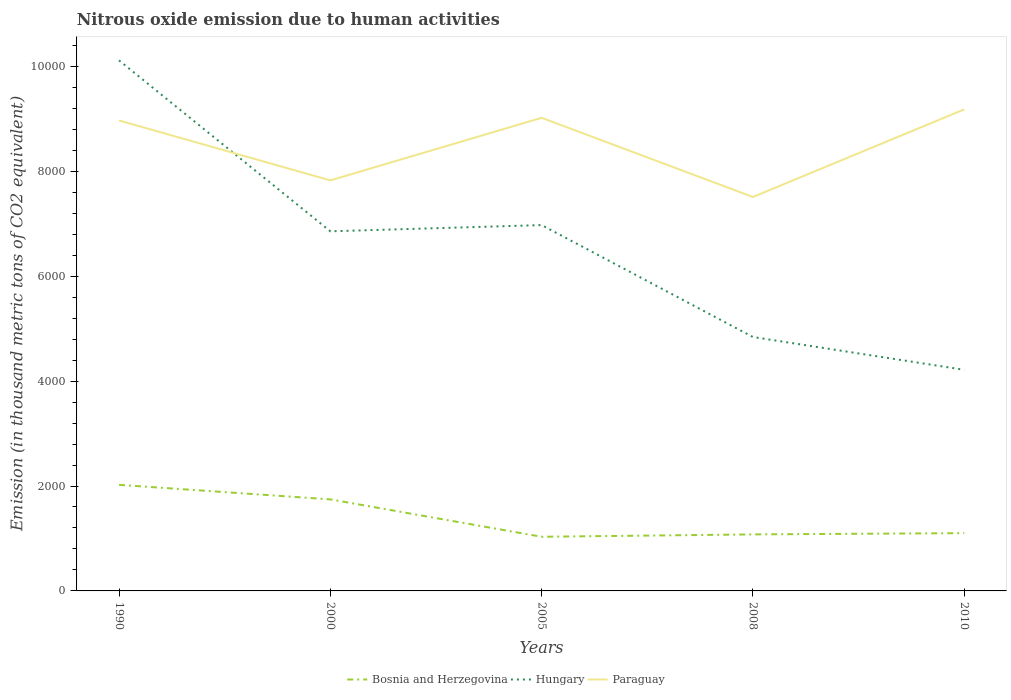How many different coloured lines are there?
Offer a terse response. 3. Does the line corresponding to Bosnia and Herzegovina intersect with the line corresponding to Hungary?
Make the answer very short. No. Is the number of lines equal to the number of legend labels?
Offer a terse response. Yes. Across all years, what is the maximum amount of nitrous oxide emitted in Bosnia and Herzegovina?
Offer a terse response. 1032.3. In which year was the amount of nitrous oxide emitted in Hungary maximum?
Provide a succinct answer. 2010. What is the total amount of nitrous oxide emitted in Paraguay in the graph?
Provide a succinct answer. -1354. What is the difference between the highest and the second highest amount of nitrous oxide emitted in Bosnia and Herzegovina?
Ensure brevity in your answer.  990.3. What is the difference between the highest and the lowest amount of nitrous oxide emitted in Bosnia and Herzegovina?
Provide a short and direct response. 2. Is the amount of nitrous oxide emitted in Bosnia and Herzegovina strictly greater than the amount of nitrous oxide emitted in Hungary over the years?
Provide a succinct answer. Yes. How many lines are there?
Provide a succinct answer. 3. How many years are there in the graph?
Your response must be concise. 5. What is the difference between two consecutive major ticks on the Y-axis?
Keep it short and to the point. 2000. Are the values on the major ticks of Y-axis written in scientific E-notation?
Provide a short and direct response. No. Does the graph contain any zero values?
Offer a terse response. No. How are the legend labels stacked?
Your response must be concise. Horizontal. What is the title of the graph?
Give a very brief answer. Nitrous oxide emission due to human activities. What is the label or title of the Y-axis?
Your answer should be compact. Emission (in thousand metric tons of CO2 equivalent). What is the Emission (in thousand metric tons of CO2 equivalent) in Bosnia and Herzegovina in 1990?
Provide a succinct answer. 2022.6. What is the Emission (in thousand metric tons of CO2 equivalent) in Hungary in 1990?
Ensure brevity in your answer.  1.01e+04. What is the Emission (in thousand metric tons of CO2 equivalent) of Paraguay in 1990?
Your answer should be compact. 8968.7. What is the Emission (in thousand metric tons of CO2 equivalent) of Bosnia and Herzegovina in 2000?
Keep it short and to the point. 1744.9. What is the Emission (in thousand metric tons of CO2 equivalent) of Hungary in 2000?
Your answer should be very brief. 6855.8. What is the Emission (in thousand metric tons of CO2 equivalent) of Paraguay in 2000?
Make the answer very short. 7826.3. What is the Emission (in thousand metric tons of CO2 equivalent) in Bosnia and Herzegovina in 2005?
Make the answer very short. 1032.3. What is the Emission (in thousand metric tons of CO2 equivalent) in Hungary in 2005?
Offer a terse response. 6974.6. What is the Emission (in thousand metric tons of CO2 equivalent) in Paraguay in 2005?
Keep it short and to the point. 9019.7. What is the Emission (in thousand metric tons of CO2 equivalent) in Bosnia and Herzegovina in 2008?
Give a very brief answer. 1077.6. What is the Emission (in thousand metric tons of CO2 equivalent) of Hungary in 2008?
Give a very brief answer. 4840.8. What is the Emission (in thousand metric tons of CO2 equivalent) of Paraguay in 2008?
Offer a very short reply. 7510.2. What is the Emission (in thousand metric tons of CO2 equivalent) in Bosnia and Herzegovina in 2010?
Make the answer very short. 1101.5. What is the Emission (in thousand metric tons of CO2 equivalent) in Hungary in 2010?
Ensure brevity in your answer.  4215.1. What is the Emission (in thousand metric tons of CO2 equivalent) of Paraguay in 2010?
Provide a short and direct response. 9180.3. Across all years, what is the maximum Emission (in thousand metric tons of CO2 equivalent) in Bosnia and Herzegovina?
Your response must be concise. 2022.6. Across all years, what is the maximum Emission (in thousand metric tons of CO2 equivalent) in Hungary?
Your answer should be compact. 1.01e+04. Across all years, what is the maximum Emission (in thousand metric tons of CO2 equivalent) of Paraguay?
Give a very brief answer. 9180.3. Across all years, what is the minimum Emission (in thousand metric tons of CO2 equivalent) of Bosnia and Herzegovina?
Offer a terse response. 1032.3. Across all years, what is the minimum Emission (in thousand metric tons of CO2 equivalent) in Hungary?
Your answer should be compact. 4215.1. Across all years, what is the minimum Emission (in thousand metric tons of CO2 equivalent) in Paraguay?
Your response must be concise. 7510.2. What is the total Emission (in thousand metric tons of CO2 equivalent) in Bosnia and Herzegovina in the graph?
Ensure brevity in your answer.  6978.9. What is the total Emission (in thousand metric tons of CO2 equivalent) of Hungary in the graph?
Ensure brevity in your answer.  3.30e+04. What is the total Emission (in thousand metric tons of CO2 equivalent) in Paraguay in the graph?
Keep it short and to the point. 4.25e+04. What is the difference between the Emission (in thousand metric tons of CO2 equivalent) of Bosnia and Herzegovina in 1990 and that in 2000?
Your answer should be very brief. 277.7. What is the difference between the Emission (in thousand metric tons of CO2 equivalent) of Hungary in 1990 and that in 2000?
Ensure brevity in your answer.  3258.4. What is the difference between the Emission (in thousand metric tons of CO2 equivalent) of Paraguay in 1990 and that in 2000?
Provide a succinct answer. 1142.4. What is the difference between the Emission (in thousand metric tons of CO2 equivalent) in Bosnia and Herzegovina in 1990 and that in 2005?
Give a very brief answer. 990.3. What is the difference between the Emission (in thousand metric tons of CO2 equivalent) of Hungary in 1990 and that in 2005?
Make the answer very short. 3139.6. What is the difference between the Emission (in thousand metric tons of CO2 equivalent) of Paraguay in 1990 and that in 2005?
Your answer should be compact. -51. What is the difference between the Emission (in thousand metric tons of CO2 equivalent) in Bosnia and Herzegovina in 1990 and that in 2008?
Your answer should be very brief. 945. What is the difference between the Emission (in thousand metric tons of CO2 equivalent) in Hungary in 1990 and that in 2008?
Give a very brief answer. 5273.4. What is the difference between the Emission (in thousand metric tons of CO2 equivalent) of Paraguay in 1990 and that in 2008?
Make the answer very short. 1458.5. What is the difference between the Emission (in thousand metric tons of CO2 equivalent) in Bosnia and Herzegovina in 1990 and that in 2010?
Your response must be concise. 921.1. What is the difference between the Emission (in thousand metric tons of CO2 equivalent) in Hungary in 1990 and that in 2010?
Give a very brief answer. 5899.1. What is the difference between the Emission (in thousand metric tons of CO2 equivalent) of Paraguay in 1990 and that in 2010?
Ensure brevity in your answer.  -211.6. What is the difference between the Emission (in thousand metric tons of CO2 equivalent) of Bosnia and Herzegovina in 2000 and that in 2005?
Keep it short and to the point. 712.6. What is the difference between the Emission (in thousand metric tons of CO2 equivalent) of Hungary in 2000 and that in 2005?
Give a very brief answer. -118.8. What is the difference between the Emission (in thousand metric tons of CO2 equivalent) of Paraguay in 2000 and that in 2005?
Give a very brief answer. -1193.4. What is the difference between the Emission (in thousand metric tons of CO2 equivalent) in Bosnia and Herzegovina in 2000 and that in 2008?
Keep it short and to the point. 667.3. What is the difference between the Emission (in thousand metric tons of CO2 equivalent) of Hungary in 2000 and that in 2008?
Make the answer very short. 2015. What is the difference between the Emission (in thousand metric tons of CO2 equivalent) of Paraguay in 2000 and that in 2008?
Ensure brevity in your answer.  316.1. What is the difference between the Emission (in thousand metric tons of CO2 equivalent) of Bosnia and Herzegovina in 2000 and that in 2010?
Offer a terse response. 643.4. What is the difference between the Emission (in thousand metric tons of CO2 equivalent) in Hungary in 2000 and that in 2010?
Make the answer very short. 2640.7. What is the difference between the Emission (in thousand metric tons of CO2 equivalent) in Paraguay in 2000 and that in 2010?
Offer a terse response. -1354. What is the difference between the Emission (in thousand metric tons of CO2 equivalent) in Bosnia and Herzegovina in 2005 and that in 2008?
Provide a succinct answer. -45.3. What is the difference between the Emission (in thousand metric tons of CO2 equivalent) of Hungary in 2005 and that in 2008?
Your response must be concise. 2133.8. What is the difference between the Emission (in thousand metric tons of CO2 equivalent) of Paraguay in 2005 and that in 2008?
Offer a terse response. 1509.5. What is the difference between the Emission (in thousand metric tons of CO2 equivalent) of Bosnia and Herzegovina in 2005 and that in 2010?
Make the answer very short. -69.2. What is the difference between the Emission (in thousand metric tons of CO2 equivalent) in Hungary in 2005 and that in 2010?
Provide a short and direct response. 2759.5. What is the difference between the Emission (in thousand metric tons of CO2 equivalent) of Paraguay in 2005 and that in 2010?
Your answer should be compact. -160.6. What is the difference between the Emission (in thousand metric tons of CO2 equivalent) of Bosnia and Herzegovina in 2008 and that in 2010?
Your answer should be compact. -23.9. What is the difference between the Emission (in thousand metric tons of CO2 equivalent) of Hungary in 2008 and that in 2010?
Keep it short and to the point. 625.7. What is the difference between the Emission (in thousand metric tons of CO2 equivalent) in Paraguay in 2008 and that in 2010?
Your answer should be compact. -1670.1. What is the difference between the Emission (in thousand metric tons of CO2 equivalent) of Bosnia and Herzegovina in 1990 and the Emission (in thousand metric tons of CO2 equivalent) of Hungary in 2000?
Your response must be concise. -4833.2. What is the difference between the Emission (in thousand metric tons of CO2 equivalent) in Bosnia and Herzegovina in 1990 and the Emission (in thousand metric tons of CO2 equivalent) in Paraguay in 2000?
Provide a succinct answer. -5803.7. What is the difference between the Emission (in thousand metric tons of CO2 equivalent) of Hungary in 1990 and the Emission (in thousand metric tons of CO2 equivalent) of Paraguay in 2000?
Offer a terse response. 2287.9. What is the difference between the Emission (in thousand metric tons of CO2 equivalent) of Bosnia and Herzegovina in 1990 and the Emission (in thousand metric tons of CO2 equivalent) of Hungary in 2005?
Ensure brevity in your answer.  -4952. What is the difference between the Emission (in thousand metric tons of CO2 equivalent) of Bosnia and Herzegovina in 1990 and the Emission (in thousand metric tons of CO2 equivalent) of Paraguay in 2005?
Give a very brief answer. -6997.1. What is the difference between the Emission (in thousand metric tons of CO2 equivalent) in Hungary in 1990 and the Emission (in thousand metric tons of CO2 equivalent) in Paraguay in 2005?
Provide a succinct answer. 1094.5. What is the difference between the Emission (in thousand metric tons of CO2 equivalent) in Bosnia and Herzegovina in 1990 and the Emission (in thousand metric tons of CO2 equivalent) in Hungary in 2008?
Your answer should be compact. -2818.2. What is the difference between the Emission (in thousand metric tons of CO2 equivalent) of Bosnia and Herzegovina in 1990 and the Emission (in thousand metric tons of CO2 equivalent) of Paraguay in 2008?
Your answer should be compact. -5487.6. What is the difference between the Emission (in thousand metric tons of CO2 equivalent) in Hungary in 1990 and the Emission (in thousand metric tons of CO2 equivalent) in Paraguay in 2008?
Offer a very short reply. 2604. What is the difference between the Emission (in thousand metric tons of CO2 equivalent) of Bosnia and Herzegovina in 1990 and the Emission (in thousand metric tons of CO2 equivalent) of Hungary in 2010?
Offer a terse response. -2192.5. What is the difference between the Emission (in thousand metric tons of CO2 equivalent) of Bosnia and Herzegovina in 1990 and the Emission (in thousand metric tons of CO2 equivalent) of Paraguay in 2010?
Give a very brief answer. -7157.7. What is the difference between the Emission (in thousand metric tons of CO2 equivalent) of Hungary in 1990 and the Emission (in thousand metric tons of CO2 equivalent) of Paraguay in 2010?
Offer a very short reply. 933.9. What is the difference between the Emission (in thousand metric tons of CO2 equivalent) of Bosnia and Herzegovina in 2000 and the Emission (in thousand metric tons of CO2 equivalent) of Hungary in 2005?
Offer a terse response. -5229.7. What is the difference between the Emission (in thousand metric tons of CO2 equivalent) of Bosnia and Herzegovina in 2000 and the Emission (in thousand metric tons of CO2 equivalent) of Paraguay in 2005?
Make the answer very short. -7274.8. What is the difference between the Emission (in thousand metric tons of CO2 equivalent) in Hungary in 2000 and the Emission (in thousand metric tons of CO2 equivalent) in Paraguay in 2005?
Your answer should be very brief. -2163.9. What is the difference between the Emission (in thousand metric tons of CO2 equivalent) in Bosnia and Herzegovina in 2000 and the Emission (in thousand metric tons of CO2 equivalent) in Hungary in 2008?
Offer a very short reply. -3095.9. What is the difference between the Emission (in thousand metric tons of CO2 equivalent) of Bosnia and Herzegovina in 2000 and the Emission (in thousand metric tons of CO2 equivalent) of Paraguay in 2008?
Provide a short and direct response. -5765.3. What is the difference between the Emission (in thousand metric tons of CO2 equivalent) in Hungary in 2000 and the Emission (in thousand metric tons of CO2 equivalent) in Paraguay in 2008?
Your answer should be very brief. -654.4. What is the difference between the Emission (in thousand metric tons of CO2 equivalent) of Bosnia and Herzegovina in 2000 and the Emission (in thousand metric tons of CO2 equivalent) of Hungary in 2010?
Offer a very short reply. -2470.2. What is the difference between the Emission (in thousand metric tons of CO2 equivalent) of Bosnia and Herzegovina in 2000 and the Emission (in thousand metric tons of CO2 equivalent) of Paraguay in 2010?
Provide a short and direct response. -7435.4. What is the difference between the Emission (in thousand metric tons of CO2 equivalent) in Hungary in 2000 and the Emission (in thousand metric tons of CO2 equivalent) in Paraguay in 2010?
Make the answer very short. -2324.5. What is the difference between the Emission (in thousand metric tons of CO2 equivalent) of Bosnia and Herzegovina in 2005 and the Emission (in thousand metric tons of CO2 equivalent) of Hungary in 2008?
Provide a succinct answer. -3808.5. What is the difference between the Emission (in thousand metric tons of CO2 equivalent) in Bosnia and Herzegovina in 2005 and the Emission (in thousand metric tons of CO2 equivalent) in Paraguay in 2008?
Offer a very short reply. -6477.9. What is the difference between the Emission (in thousand metric tons of CO2 equivalent) in Hungary in 2005 and the Emission (in thousand metric tons of CO2 equivalent) in Paraguay in 2008?
Keep it short and to the point. -535.6. What is the difference between the Emission (in thousand metric tons of CO2 equivalent) of Bosnia and Herzegovina in 2005 and the Emission (in thousand metric tons of CO2 equivalent) of Hungary in 2010?
Provide a succinct answer. -3182.8. What is the difference between the Emission (in thousand metric tons of CO2 equivalent) of Bosnia and Herzegovina in 2005 and the Emission (in thousand metric tons of CO2 equivalent) of Paraguay in 2010?
Make the answer very short. -8148. What is the difference between the Emission (in thousand metric tons of CO2 equivalent) of Hungary in 2005 and the Emission (in thousand metric tons of CO2 equivalent) of Paraguay in 2010?
Offer a very short reply. -2205.7. What is the difference between the Emission (in thousand metric tons of CO2 equivalent) of Bosnia and Herzegovina in 2008 and the Emission (in thousand metric tons of CO2 equivalent) of Hungary in 2010?
Make the answer very short. -3137.5. What is the difference between the Emission (in thousand metric tons of CO2 equivalent) of Bosnia and Herzegovina in 2008 and the Emission (in thousand metric tons of CO2 equivalent) of Paraguay in 2010?
Provide a short and direct response. -8102.7. What is the difference between the Emission (in thousand metric tons of CO2 equivalent) in Hungary in 2008 and the Emission (in thousand metric tons of CO2 equivalent) in Paraguay in 2010?
Offer a terse response. -4339.5. What is the average Emission (in thousand metric tons of CO2 equivalent) in Bosnia and Herzegovina per year?
Give a very brief answer. 1395.78. What is the average Emission (in thousand metric tons of CO2 equivalent) in Hungary per year?
Give a very brief answer. 6600.1. What is the average Emission (in thousand metric tons of CO2 equivalent) in Paraguay per year?
Make the answer very short. 8501.04. In the year 1990, what is the difference between the Emission (in thousand metric tons of CO2 equivalent) in Bosnia and Herzegovina and Emission (in thousand metric tons of CO2 equivalent) in Hungary?
Your answer should be compact. -8091.6. In the year 1990, what is the difference between the Emission (in thousand metric tons of CO2 equivalent) in Bosnia and Herzegovina and Emission (in thousand metric tons of CO2 equivalent) in Paraguay?
Provide a succinct answer. -6946.1. In the year 1990, what is the difference between the Emission (in thousand metric tons of CO2 equivalent) in Hungary and Emission (in thousand metric tons of CO2 equivalent) in Paraguay?
Offer a very short reply. 1145.5. In the year 2000, what is the difference between the Emission (in thousand metric tons of CO2 equivalent) of Bosnia and Herzegovina and Emission (in thousand metric tons of CO2 equivalent) of Hungary?
Your response must be concise. -5110.9. In the year 2000, what is the difference between the Emission (in thousand metric tons of CO2 equivalent) of Bosnia and Herzegovina and Emission (in thousand metric tons of CO2 equivalent) of Paraguay?
Your answer should be compact. -6081.4. In the year 2000, what is the difference between the Emission (in thousand metric tons of CO2 equivalent) in Hungary and Emission (in thousand metric tons of CO2 equivalent) in Paraguay?
Your answer should be very brief. -970.5. In the year 2005, what is the difference between the Emission (in thousand metric tons of CO2 equivalent) in Bosnia and Herzegovina and Emission (in thousand metric tons of CO2 equivalent) in Hungary?
Provide a succinct answer. -5942.3. In the year 2005, what is the difference between the Emission (in thousand metric tons of CO2 equivalent) of Bosnia and Herzegovina and Emission (in thousand metric tons of CO2 equivalent) of Paraguay?
Your answer should be compact. -7987.4. In the year 2005, what is the difference between the Emission (in thousand metric tons of CO2 equivalent) of Hungary and Emission (in thousand metric tons of CO2 equivalent) of Paraguay?
Ensure brevity in your answer.  -2045.1. In the year 2008, what is the difference between the Emission (in thousand metric tons of CO2 equivalent) of Bosnia and Herzegovina and Emission (in thousand metric tons of CO2 equivalent) of Hungary?
Your answer should be compact. -3763.2. In the year 2008, what is the difference between the Emission (in thousand metric tons of CO2 equivalent) in Bosnia and Herzegovina and Emission (in thousand metric tons of CO2 equivalent) in Paraguay?
Provide a succinct answer. -6432.6. In the year 2008, what is the difference between the Emission (in thousand metric tons of CO2 equivalent) in Hungary and Emission (in thousand metric tons of CO2 equivalent) in Paraguay?
Keep it short and to the point. -2669.4. In the year 2010, what is the difference between the Emission (in thousand metric tons of CO2 equivalent) of Bosnia and Herzegovina and Emission (in thousand metric tons of CO2 equivalent) of Hungary?
Make the answer very short. -3113.6. In the year 2010, what is the difference between the Emission (in thousand metric tons of CO2 equivalent) of Bosnia and Herzegovina and Emission (in thousand metric tons of CO2 equivalent) of Paraguay?
Your answer should be very brief. -8078.8. In the year 2010, what is the difference between the Emission (in thousand metric tons of CO2 equivalent) in Hungary and Emission (in thousand metric tons of CO2 equivalent) in Paraguay?
Provide a short and direct response. -4965.2. What is the ratio of the Emission (in thousand metric tons of CO2 equivalent) in Bosnia and Herzegovina in 1990 to that in 2000?
Make the answer very short. 1.16. What is the ratio of the Emission (in thousand metric tons of CO2 equivalent) of Hungary in 1990 to that in 2000?
Provide a short and direct response. 1.48. What is the ratio of the Emission (in thousand metric tons of CO2 equivalent) in Paraguay in 1990 to that in 2000?
Give a very brief answer. 1.15. What is the ratio of the Emission (in thousand metric tons of CO2 equivalent) in Bosnia and Herzegovina in 1990 to that in 2005?
Your response must be concise. 1.96. What is the ratio of the Emission (in thousand metric tons of CO2 equivalent) of Hungary in 1990 to that in 2005?
Your answer should be compact. 1.45. What is the ratio of the Emission (in thousand metric tons of CO2 equivalent) of Paraguay in 1990 to that in 2005?
Your answer should be compact. 0.99. What is the ratio of the Emission (in thousand metric tons of CO2 equivalent) in Bosnia and Herzegovina in 1990 to that in 2008?
Offer a terse response. 1.88. What is the ratio of the Emission (in thousand metric tons of CO2 equivalent) in Hungary in 1990 to that in 2008?
Ensure brevity in your answer.  2.09. What is the ratio of the Emission (in thousand metric tons of CO2 equivalent) of Paraguay in 1990 to that in 2008?
Provide a short and direct response. 1.19. What is the ratio of the Emission (in thousand metric tons of CO2 equivalent) in Bosnia and Herzegovina in 1990 to that in 2010?
Your response must be concise. 1.84. What is the ratio of the Emission (in thousand metric tons of CO2 equivalent) of Hungary in 1990 to that in 2010?
Make the answer very short. 2.4. What is the ratio of the Emission (in thousand metric tons of CO2 equivalent) in Bosnia and Herzegovina in 2000 to that in 2005?
Offer a very short reply. 1.69. What is the ratio of the Emission (in thousand metric tons of CO2 equivalent) in Hungary in 2000 to that in 2005?
Your answer should be compact. 0.98. What is the ratio of the Emission (in thousand metric tons of CO2 equivalent) of Paraguay in 2000 to that in 2005?
Offer a very short reply. 0.87. What is the ratio of the Emission (in thousand metric tons of CO2 equivalent) of Bosnia and Herzegovina in 2000 to that in 2008?
Your answer should be compact. 1.62. What is the ratio of the Emission (in thousand metric tons of CO2 equivalent) of Hungary in 2000 to that in 2008?
Ensure brevity in your answer.  1.42. What is the ratio of the Emission (in thousand metric tons of CO2 equivalent) of Paraguay in 2000 to that in 2008?
Your answer should be very brief. 1.04. What is the ratio of the Emission (in thousand metric tons of CO2 equivalent) in Bosnia and Herzegovina in 2000 to that in 2010?
Provide a succinct answer. 1.58. What is the ratio of the Emission (in thousand metric tons of CO2 equivalent) of Hungary in 2000 to that in 2010?
Your answer should be very brief. 1.63. What is the ratio of the Emission (in thousand metric tons of CO2 equivalent) in Paraguay in 2000 to that in 2010?
Provide a short and direct response. 0.85. What is the ratio of the Emission (in thousand metric tons of CO2 equivalent) in Bosnia and Herzegovina in 2005 to that in 2008?
Ensure brevity in your answer.  0.96. What is the ratio of the Emission (in thousand metric tons of CO2 equivalent) of Hungary in 2005 to that in 2008?
Offer a very short reply. 1.44. What is the ratio of the Emission (in thousand metric tons of CO2 equivalent) of Paraguay in 2005 to that in 2008?
Make the answer very short. 1.2. What is the ratio of the Emission (in thousand metric tons of CO2 equivalent) in Bosnia and Herzegovina in 2005 to that in 2010?
Ensure brevity in your answer.  0.94. What is the ratio of the Emission (in thousand metric tons of CO2 equivalent) in Hungary in 2005 to that in 2010?
Your response must be concise. 1.65. What is the ratio of the Emission (in thousand metric tons of CO2 equivalent) in Paraguay in 2005 to that in 2010?
Keep it short and to the point. 0.98. What is the ratio of the Emission (in thousand metric tons of CO2 equivalent) in Bosnia and Herzegovina in 2008 to that in 2010?
Ensure brevity in your answer.  0.98. What is the ratio of the Emission (in thousand metric tons of CO2 equivalent) in Hungary in 2008 to that in 2010?
Keep it short and to the point. 1.15. What is the ratio of the Emission (in thousand metric tons of CO2 equivalent) of Paraguay in 2008 to that in 2010?
Your answer should be compact. 0.82. What is the difference between the highest and the second highest Emission (in thousand metric tons of CO2 equivalent) of Bosnia and Herzegovina?
Provide a short and direct response. 277.7. What is the difference between the highest and the second highest Emission (in thousand metric tons of CO2 equivalent) of Hungary?
Provide a succinct answer. 3139.6. What is the difference between the highest and the second highest Emission (in thousand metric tons of CO2 equivalent) of Paraguay?
Ensure brevity in your answer.  160.6. What is the difference between the highest and the lowest Emission (in thousand metric tons of CO2 equivalent) of Bosnia and Herzegovina?
Provide a short and direct response. 990.3. What is the difference between the highest and the lowest Emission (in thousand metric tons of CO2 equivalent) in Hungary?
Give a very brief answer. 5899.1. What is the difference between the highest and the lowest Emission (in thousand metric tons of CO2 equivalent) of Paraguay?
Keep it short and to the point. 1670.1. 